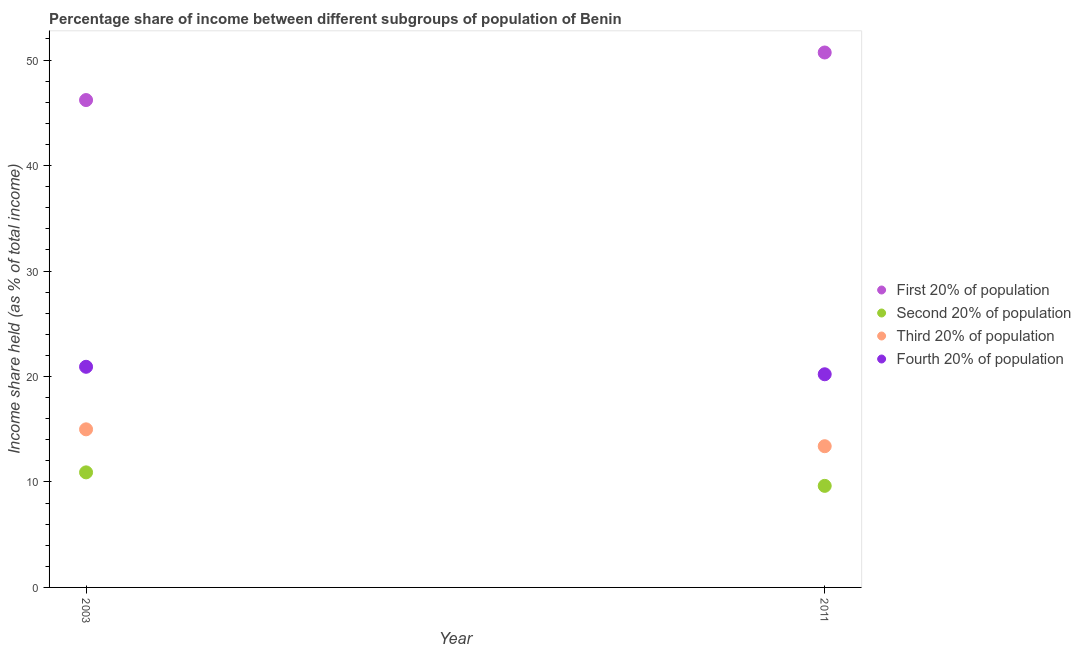What is the share of the income held by fourth 20% of the population in 2003?
Offer a very short reply. 20.92. Across all years, what is the maximum share of the income held by second 20% of the population?
Your answer should be very brief. 10.91. Across all years, what is the minimum share of the income held by third 20% of the population?
Offer a very short reply. 13.39. In which year was the share of the income held by third 20% of the population maximum?
Your answer should be very brief. 2003. What is the total share of the income held by first 20% of the population in the graph?
Keep it short and to the point. 96.93. What is the difference between the share of the income held by fourth 20% of the population in 2003 and that in 2011?
Give a very brief answer. 0.71. What is the difference between the share of the income held by fourth 20% of the population in 2011 and the share of the income held by second 20% of the population in 2003?
Make the answer very short. 9.3. What is the average share of the income held by third 20% of the population per year?
Provide a succinct answer. 14.19. In the year 2003, what is the difference between the share of the income held by fourth 20% of the population and share of the income held by third 20% of the population?
Provide a succinct answer. 5.93. In how many years, is the share of the income held by first 20% of the population greater than 24 %?
Provide a short and direct response. 2. What is the ratio of the share of the income held by first 20% of the population in 2003 to that in 2011?
Your response must be concise. 0.91. Is the share of the income held by fourth 20% of the population in 2003 less than that in 2011?
Make the answer very short. No. In how many years, is the share of the income held by second 20% of the population greater than the average share of the income held by second 20% of the population taken over all years?
Ensure brevity in your answer.  1. Is it the case that in every year, the sum of the share of the income held by fourth 20% of the population and share of the income held by second 20% of the population is greater than the sum of share of the income held by third 20% of the population and share of the income held by first 20% of the population?
Keep it short and to the point. Yes. Does the share of the income held by second 20% of the population monotonically increase over the years?
Keep it short and to the point. No. Is the share of the income held by second 20% of the population strictly greater than the share of the income held by fourth 20% of the population over the years?
Make the answer very short. No. Is the share of the income held by fourth 20% of the population strictly less than the share of the income held by first 20% of the population over the years?
Your answer should be very brief. Yes. How many dotlines are there?
Your answer should be compact. 4. How many years are there in the graph?
Provide a short and direct response. 2. Does the graph contain any zero values?
Provide a succinct answer. No. Does the graph contain grids?
Keep it short and to the point. No. Where does the legend appear in the graph?
Your response must be concise. Center right. How are the legend labels stacked?
Your answer should be very brief. Vertical. What is the title of the graph?
Your response must be concise. Percentage share of income between different subgroups of population of Benin. What is the label or title of the Y-axis?
Make the answer very short. Income share held (as % of total income). What is the Income share held (as % of total income) of First 20% of population in 2003?
Ensure brevity in your answer.  46.21. What is the Income share held (as % of total income) in Second 20% of population in 2003?
Give a very brief answer. 10.91. What is the Income share held (as % of total income) in Third 20% of population in 2003?
Your response must be concise. 14.99. What is the Income share held (as % of total income) of Fourth 20% of population in 2003?
Your answer should be compact. 20.92. What is the Income share held (as % of total income) of First 20% of population in 2011?
Provide a short and direct response. 50.72. What is the Income share held (as % of total income) of Second 20% of population in 2011?
Offer a very short reply. 9.63. What is the Income share held (as % of total income) of Third 20% of population in 2011?
Offer a very short reply. 13.39. What is the Income share held (as % of total income) of Fourth 20% of population in 2011?
Your response must be concise. 20.21. Across all years, what is the maximum Income share held (as % of total income) of First 20% of population?
Provide a short and direct response. 50.72. Across all years, what is the maximum Income share held (as % of total income) in Second 20% of population?
Offer a very short reply. 10.91. Across all years, what is the maximum Income share held (as % of total income) in Third 20% of population?
Give a very brief answer. 14.99. Across all years, what is the maximum Income share held (as % of total income) in Fourth 20% of population?
Offer a very short reply. 20.92. Across all years, what is the minimum Income share held (as % of total income) of First 20% of population?
Keep it short and to the point. 46.21. Across all years, what is the minimum Income share held (as % of total income) in Second 20% of population?
Provide a succinct answer. 9.63. Across all years, what is the minimum Income share held (as % of total income) of Third 20% of population?
Keep it short and to the point. 13.39. Across all years, what is the minimum Income share held (as % of total income) of Fourth 20% of population?
Your answer should be compact. 20.21. What is the total Income share held (as % of total income) of First 20% of population in the graph?
Give a very brief answer. 96.93. What is the total Income share held (as % of total income) of Second 20% of population in the graph?
Your answer should be very brief. 20.54. What is the total Income share held (as % of total income) of Third 20% of population in the graph?
Offer a very short reply. 28.38. What is the total Income share held (as % of total income) of Fourth 20% of population in the graph?
Keep it short and to the point. 41.13. What is the difference between the Income share held (as % of total income) of First 20% of population in 2003 and that in 2011?
Keep it short and to the point. -4.51. What is the difference between the Income share held (as % of total income) in Second 20% of population in 2003 and that in 2011?
Keep it short and to the point. 1.28. What is the difference between the Income share held (as % of total income) in Third 20% of population in 2003 and that in 2011?
Your answer should be compact. 1.6. What is the difference between the Income share held (as % of total income) of Fourth 20% of population in 2003 and that in 2011?
Make the answer very short. 0.71. What is the difference between the Income share held (as % of total income) in First 20% of population in 2003 and the Income share held (as % of total income) in Second 20% of population in 2011?
Your answer should be very brief. 36.58. What is the difference between the Income share held (as % of total income) in First 20% of population in 2003 and the Income share held (as % of total income) in Third 20% of population in 2011?
Keep it short and to the point. 32.82. What is the difference between the Income share held (as % of total income) in First 20% of population in 2003 and the Income share held (as % of total income) in Fourth 20% of population in 2011?
Make the answer very short. 26. What is the difference between the Income share held (as % of total income) in Second 20% of population in 2003 and the Income share held (as % of total income) in Third 20% of population in 2011?
Give a very brief answer. -2.48. What is the difference between the Income share held (as % of total income) in Second 20% of population in 2003 and the Income share held (as % of total income) in Fourth 20% of population in 2011?
Offer a very short reply. -9.3. What is the difference between the Income share held (as % of total income) of Third 20% of population in 2003 and the Income share held (as % of total income) of Fourth 20% of population in 2011?
Provide a succinct answer. -5.22. What is the average Income share held (as % of total income) in First 20% of population per year?
Ensure brevity in your answer.  48.47. What is the average Income share held (as % of total income) of Second 20% of population per year?
Ensure brevity in your answer.  10.27. What is the average Income share held (as % of total income) in Third 20% of population per year?
Ensure brevity in your answer.  14.19. What is the average Income share held (as % of total income) in Fourth 20% of population per year?
Offer a terse response. 20.57. In the year 2003, what is the difference between the Income share held (as % of total income) of First 20% of population and Income share held (as % of total income) of Second 20% of population?
Make the answer very short. 35.3. In the year 2003, what is the difference between the Income share held (as % of total income) in First 20% of population and Income share held (as % of total income) in Third 20% of population?
Offer a terse response. 31.22. In the year 2003, what is the difference between the Income share held (as % of total income) in First 20% of population and Income share held (as % of total income) in Fourth 20% of population?
Provide a succinct answer. 25.29. In the year 2003, what is the difference between the Income share held (as % of total income) of Second 20% of population and Income share held (as % of total income) of Third 20% of population?
Provide a short and direct response. -4.08. In the year 2003, what is the difference between the Income share held (as % of total income) of Second 20% of population and Income share held (as % of total income) of Fourth 20% of population?
Your answer should be very brief. -10.01. In the year 2003, what is the difference between the Income share held (as % of total income) of Third 20% of population and Income share held (as % of total income) of Fourth 20% of population?
Your answer should be compact. -5.93. In the year 2011, what is the difference between the Income share held (as % of total income) of First 20% of population and Income share held (as % of total income) of Second 20% of population?
Offer a very short reply. 41.09. In the year 2011, what is the difference between the Income share held (as % of total income) of First 20% of population and Income share held (as % of total income) of Third 20% of population?
Provide a succinct answer. 37.33. In the year 2011, what is the difference between the Income share held (as % of total income) of First 20% of population and Income share held (as % of total income) of Fourth 20% of population?
Keep it short and to the point. 30.51. In the year 2011, what is the difference between the Income share held (as % of total income) in Second 20% of population and Income share held (as % of total income) in Third 20% of population?
Your answer should be compact. -3.76. In the year 2011, what is the difference between the Income share held (as % of total income) of Second 20% of population and Income share held (as % of total income) of Fourth 20% of population?
Keep it short and to the point. -10.58. In the year 2011, what is the difference between the Income share held (as % of total income) in Third 20% of population and Income share held (as % of total income) in Fourth 20% of population?
Offer a very short reply. -6.82. What is the ratio of the Income share held (as % of total income) of First 20% of population in 2003 to that in 2011?
Your response must be concise. 0.91. What is the ratio of the Income share held (as % of total income) of Second 20% of population in 2003 to that in 2011?
Give a very brief answer. 1.13. What is the ratio of the Income share held (as % of total income) in Third 20% of population in 2003 to that in 2011?
Offer a terse response. 1.12. What is the ratio of the Income share held (as % of total income) of Fourth 20% of population in 2003 to that in 2011?
Your answer should be compact. 1.04. What is the difference between the highest and the second highest Income share held (as % of total income) in First 20% of population?
Ensure brevity in your answer.  4.51. What is the difference between the highest and the second highest Income share held (as % of total income) of Second 20% of population?
Provide a short and direct response. 1.28. What is the difference between the highest and the second highest Income share held (as % of total income) of Fourth 20% of population?
Your answer should be very brief. 0.71. What is the difference between the highest and the lowest Income share held (as % of total income) in First 20% of population?
Provide a short and direct response. 4.51. What is the difference between the highest and the lowest Income share held (as % of total income) of Second 20% of population?
Offer a very short reply. 1.28. What is the difference between the highest and the lowest Income share held (as % of total income) in Fourth 20% of population?
Your response must be concise. 0.71. 